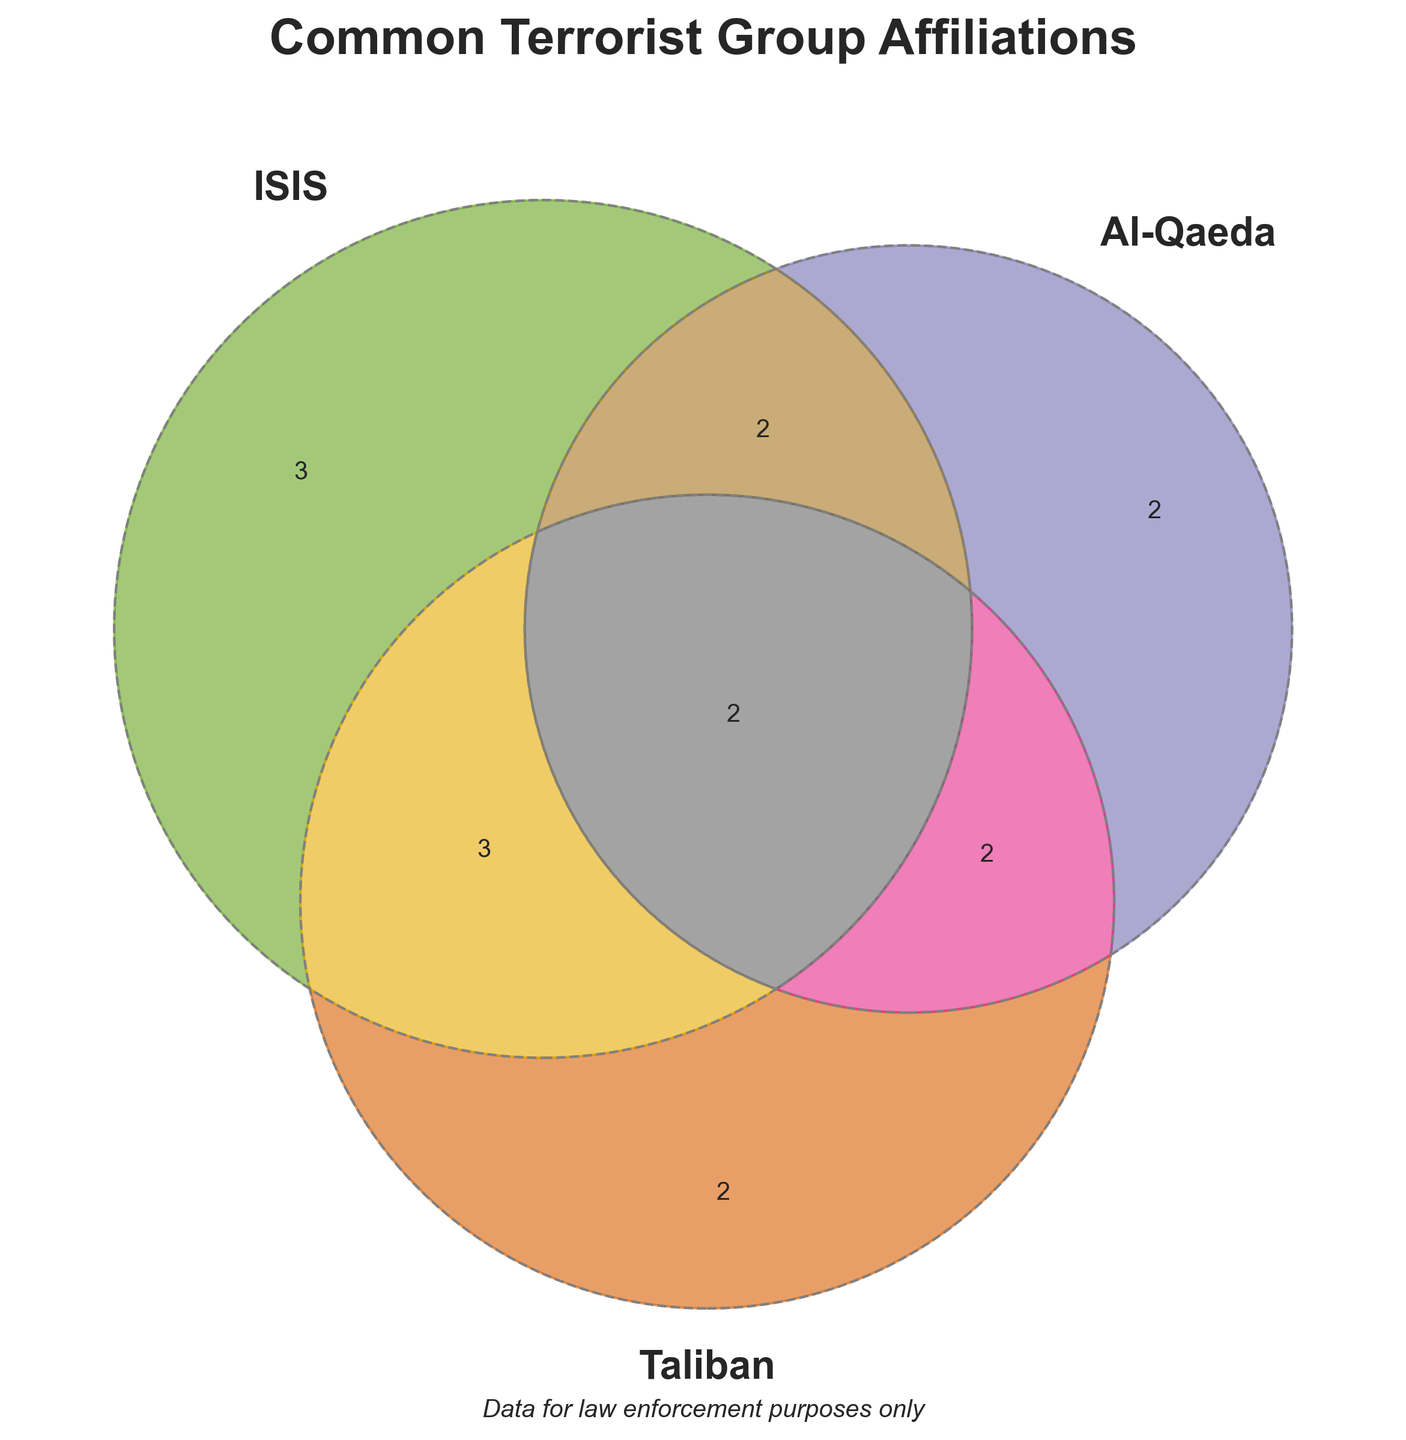What are the three terrorist groups shown in the diagram? The title and labels in the Venn diagram show the three groups involved in the analysis.
Answer: ISIS, Al-Qaeda, Taliban What is the shared affiliation between ISIS and Al-Qaeda but not with Taliban? The section where only ISIS and Al-Qaeda overlap (without Taliban) is represented.
Answer: Foreign Fighters Which overlaps among the groups share "Social Media"? The overlaps involving ISIS and Taliban but not Al-Qaeda, as shown by their respective section in the Venn diagram.
Answer: ISIS and Taliban Which affiliation is shared by all three groups? The area where the three circles intersect indicates common affiliations among all three groups.
Answer: Weapons Trafficking Name one unique affiliation of Al-Qaeda. Reviewing the Venn diagram section only representing Al-Qaeda.
Answer: Global Network How many shared affiliations are only between Al-Qaeda and Taliban? Identify the section where Al-Qaeda and Taliban overlap without including ISIS.
Answer: 1 Which group overlaps with the affiliation "Cyber Attacks"? Look at the section of the Venn diagram where this specific affiliation is placed.
Answer: ISIS What do the color variations in the diagram represent? The different colors denote different sections and intersections among the terrorist groups.
Answer: Group intersections Which group has affiliations with "Online Recruitment" and "Global Network" without sharing with others? Inspect the individual sections corresponding to each group.
Answer: ISIS (Online Recruitment), Al-Qaeda (Global Network) What does the dashed line around the circles signify? Observing the overall elements of the Venn diagram to understand the meaning of specific marks.
Answer: It indicates the boundaries of each group’s affiliations 